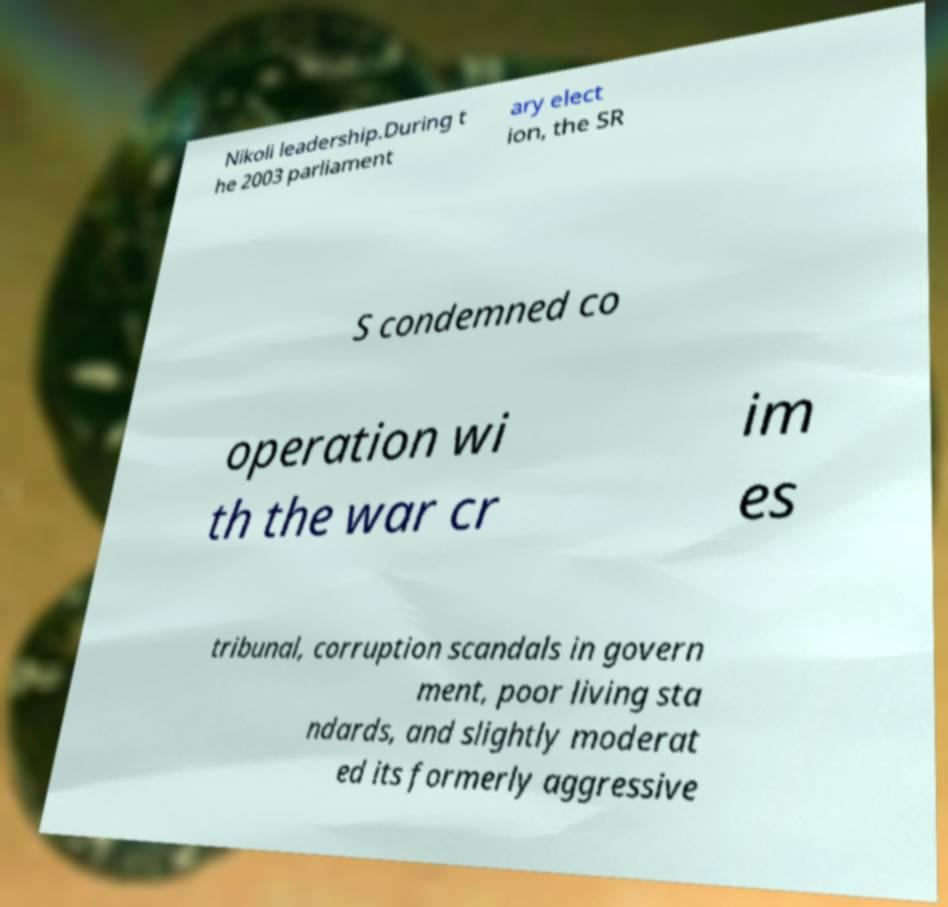Could you assist in decoding the text presented in this image and type it out clearly? Nikoli leadership.During t he 2003 parliament ary elect ion, the SR S condemned co operation wi th the war cr im es tribunal, corruption scandals in govern ment, poor living sta ndards, and slightly moderat ed its formerly aggressive 